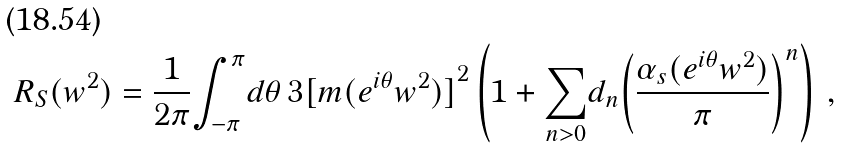Convert formula to latex. <formula><loc_0><loc_0><loc_500><loc_500>R _ { S } ( w ^ { 2 } ) = \frac { 1 } { 2 { \pi } } { \int _ { - { \pi } } ^ { \pi } } { d { \theta } } \, 3 { [ { m } ( { e } ^ { i { \theta } } { w ^ { 2 } } ) ] } ^ { 2 } \left ( 1 + { \sum _ { n > 0 } } { d _ { n } } { \left ( \frac { { \alpha } _ { s } ( { e } ^ { i { \theta } } { w ^ { 2 } } ) } { \pi } \right ) } ^ { n } \right ) \, ,</formula> 